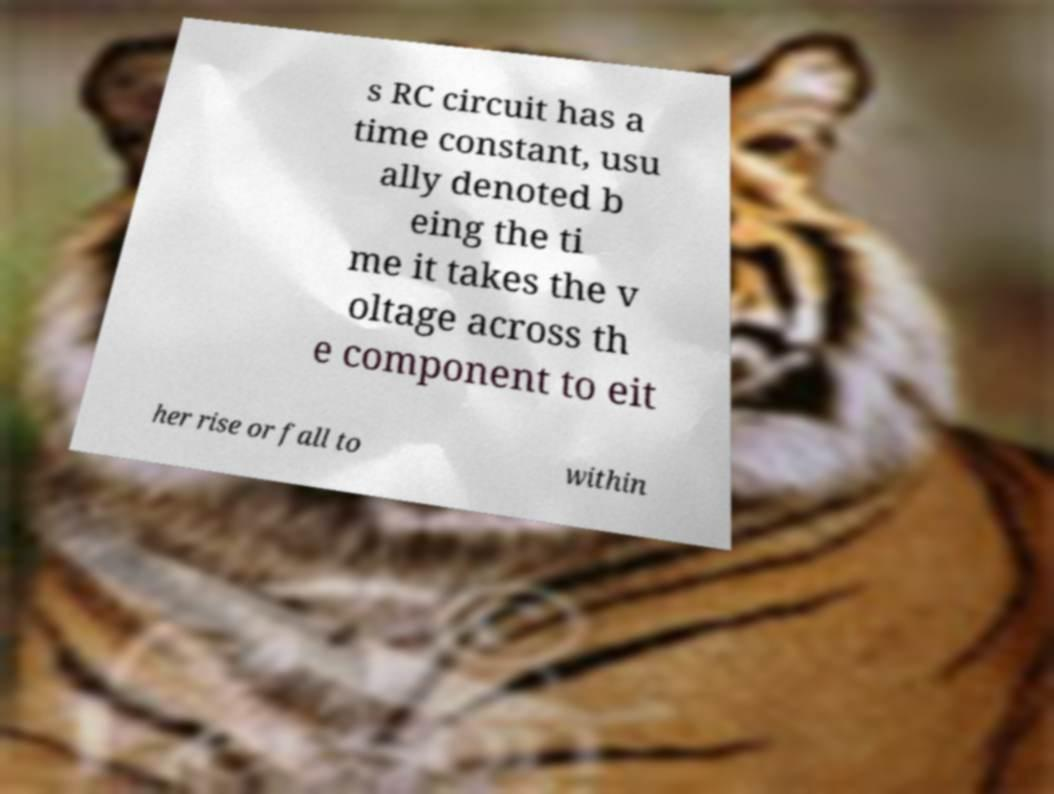There's text embedded in this image that I need extracted. Can you transcribe it verbatim? s RC circuit has a time constant, usu ally denoted b eing the ti me it takes the v oltage across th e component to eit her rise or fall to within 